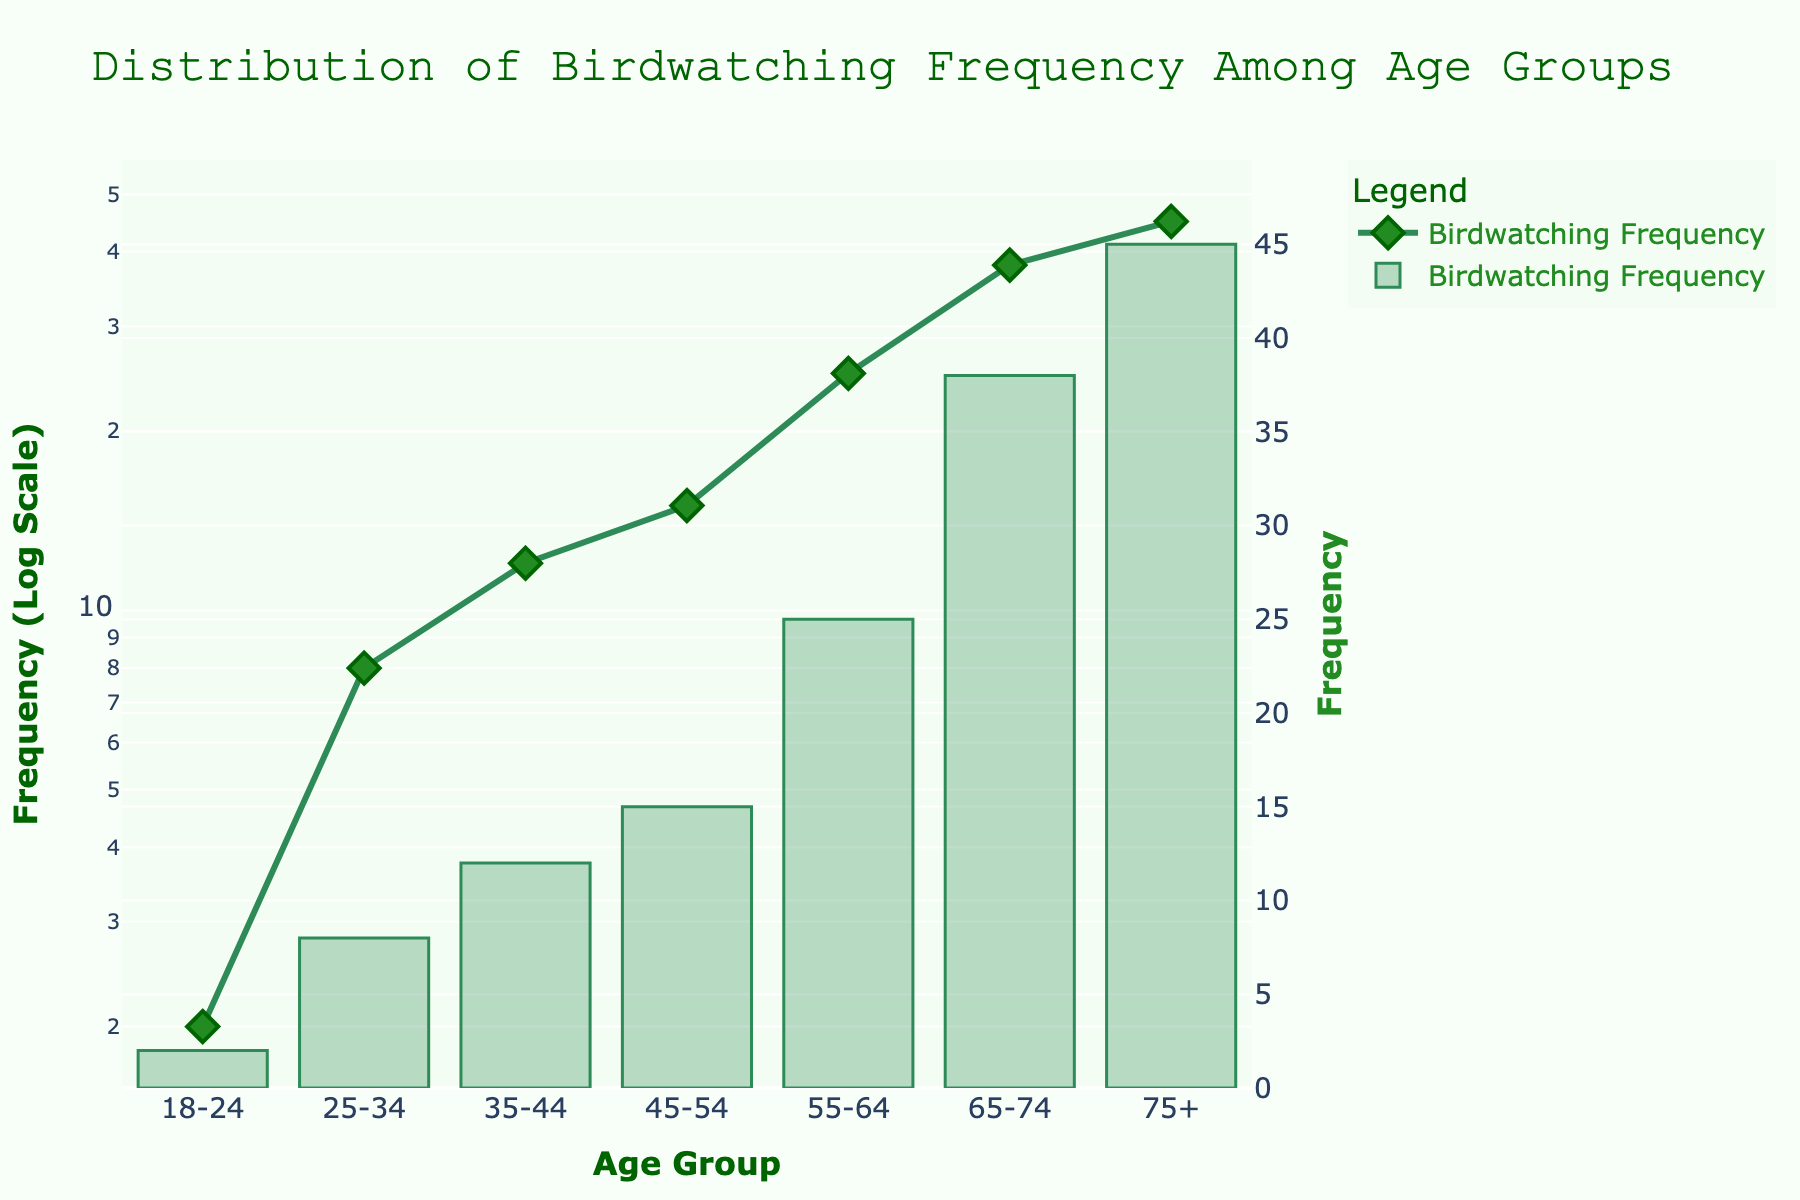What's the title of the figure? The title of the figure is prominently displayed at the top. It states "Distribution of Birdwatching Frequency Among Age Groups."
Answer: Distribution of Birdwatching Frequency Among Age Groups What color is used for the line in the scatter plot? The color for the line in the scatter plot is a shade of green.
Answer: Green Which age group has the highest birdwatching frequency? By examining the highest point on the y-axis of the plot, we see that the "75+" age group has the highest birdwatching frequency.
Answer: 75+ What's the birdwatching frequency for the 55-64 age group? The point corresponding to the 55-64 age group on the y-axis shows that the birdwatching frequency is 25.
Answer: 25 How does the birdwatching frequency for the 35-44 age group compare to the 45-54 age group? The birdwatching frequency for the 35-44 age group is 12, whereas for the 45-54 age group, it is 15. Thus, the 45-54 age group has a higher frequency than the 35-44 age group.
Answer: 45-54 has a higher frequency What is the median value of birdwatching frequency among all age groups? To find the median, list the birdwatching frequencies in numerical order: 2, 8, 12, 15, 25, 38, 45. The middle value is 15.
Answer: 15 What is the overall trend of birdwatching frequency across the age groups? Observing the plot, there is a general upward trend in birdwatching frequency as the age group increases.
Answer: Upward trend What is the range of birdwatching frequency in the plot? The range is calculated by subtracting the smallest frequency (2) from the largest frequency (45), resulting in a range of 43.
Answer: 43 How many age groups are displayed in the figure? Counting the different age groups listed along the x-axis shows that there are 7 age groups displayed.
Answer: 7 Which age groups have a birdwatching frequency greater than 10? Examining the y-values, the age groups with frequencies greater than 10 are 35-44, 45-54, 55-64, 65-74, and 75+.
Answer: 35-44, 45-54, 55-64, 65-74, 75+ 